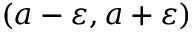<formula> <loc_0><loc_0><loc_500><loc_500>( a - \varepsilon , a + \varepsilon )</formula> 